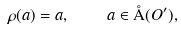<formula> <loc_0><loc_0><loc_500><loc_500>\rho ( a ) = a , \quad a \in \AA ( O ^ { \prime } ) ,</formula> 